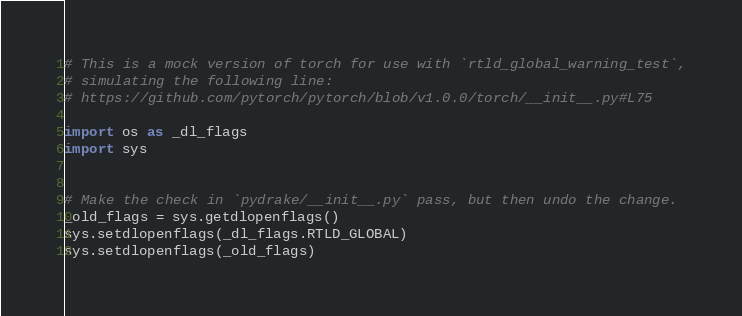<code> <loc_0><loc_0><loc_500><loc_500><_Python_># This is a mock version of torch for use with `rtld_global_warning_test`,
# simulating the following line:
# https://github.com/pytorch/pytorch/blob/v1.0.0/torch/__init__.py#L75

import os as _dl_flags
import sys


# Make the check in `pydrake/__init__.py` pass, but then undo the change.
_old_flags = sys.getdlopenflags()
sys.setdlopenflags(_dl_flags.RTLD_GLOBAL)
sys.setdlopenflags(_old_flags)
</code> 